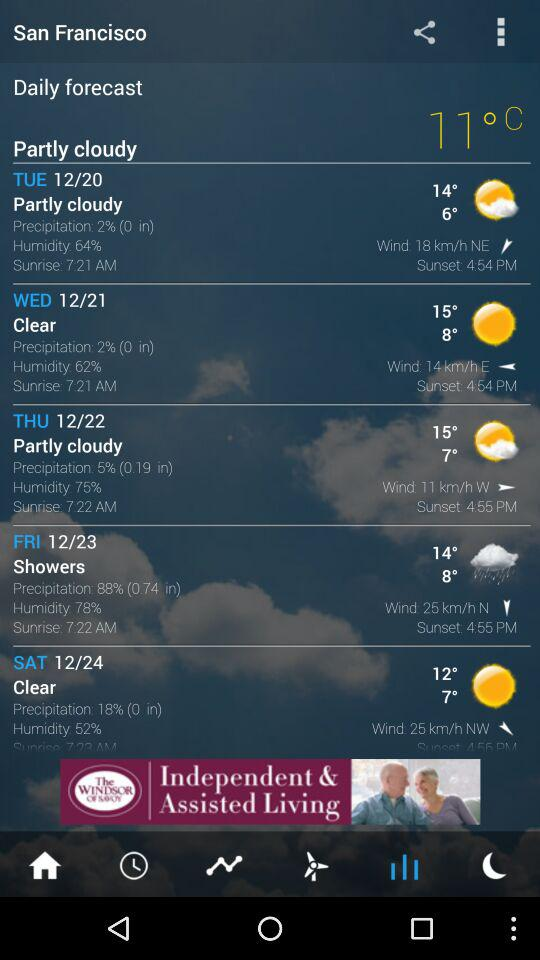What is the precipitation probability for Friday?
Answer the question using a single word or phrase. 88% 